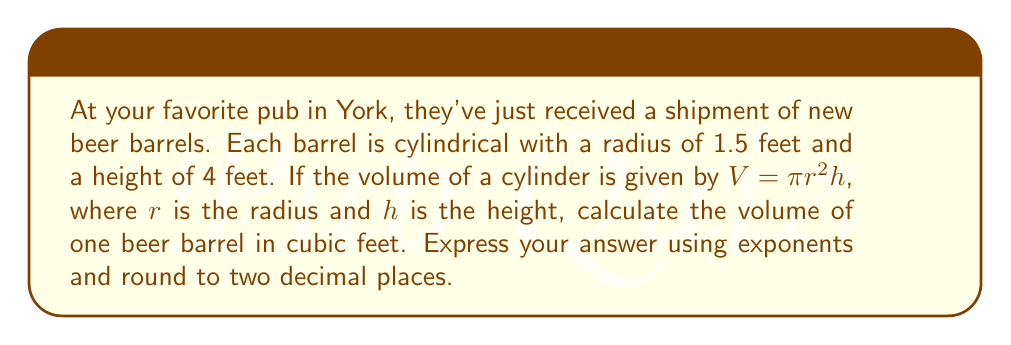Could you help me with this problem? Let's approach this step-by-step:

1) We're given the formula for the volume of a cylinder:
   $V = \pi r^2 h$

2) We know:
   - Radius (r) = 1.5 feet
   - Height (h) = 4 feet

3) Let's substitute these values into the formula:
   $V = \pi (1.5)^2 (4)$

4) First, let's calculate $(1.5)^2$:
   $(1.5)^2 = 2.25$

5) Now our equation looks like:
   $V = \pi (2.25) (4)$

6) Multiply the numbers:
   $V = \pi (9)$

7) $\pi$ to 5 decimal places is 3.14159, so:
   $V = 3.14159 (9)$

8) Multiply:
   $V = 28.27431$

9) Rounding to two decimal places:
   $V = 28.27$

10) To express this using exponents, we can write:
    $V = 2.827 \times 10^1$ cubic feet
Answer: $2.827 \times 10^1$ cubic feet 